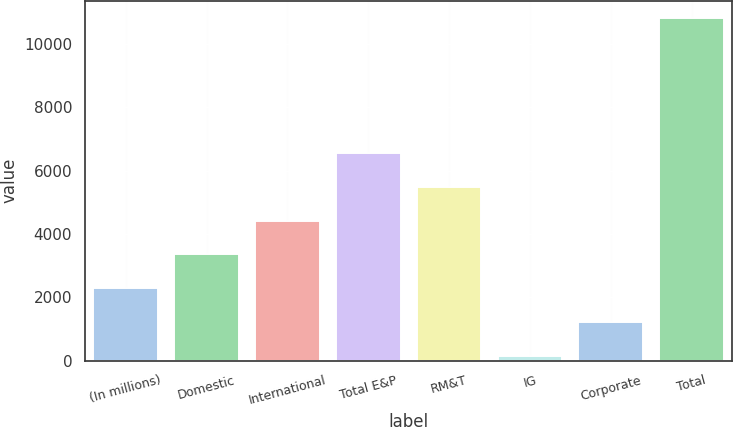Convert chart to OTSL. <chart><loc_0><loc_0><loc_500><loc_500><bar_chart><fcel>(In millions)<fcel>Domestic<fcel>International<fcel>Total E&P<fcel>RM&T<fcel>IG<fcel>Corporate<fcel>Total<nl><fcel>2288.4<fcel>3356.1<fcel>4423.8<fcel>6559.2<fcel>5491.5<fcel>153<fcel>1220.7<fcel>10830<nl></chart> 